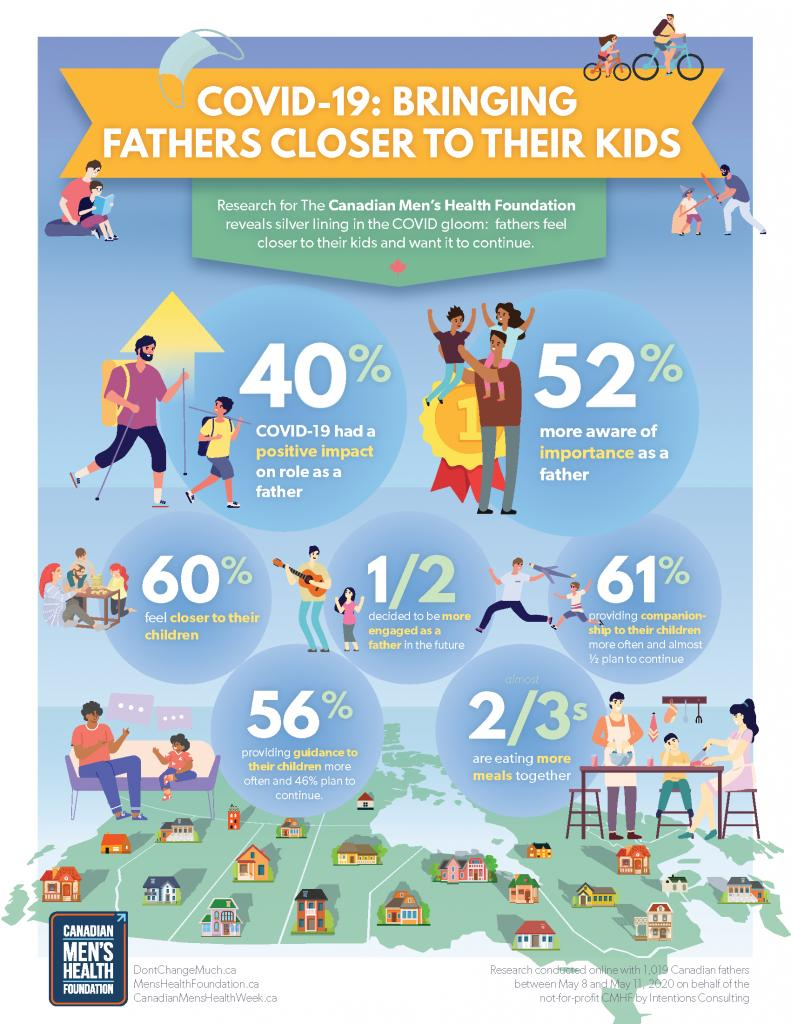Give some essential details in this illustration. According to a study conducted by the Canadian Mental Health Foundation, 60% of Canadian fathers reported feeling a stronger bond with their children during the COVID-19 pandemic. According to a study conducted by the Canadian Mental Health Foundation, a majority of Canadian fathers, 61%, provided companionship to their children more often during the COVID-19 period as compared to before the pandemic. According to the research conducted by CMHF, a significant portion of the Canadian men population has expressed a desire to be more engaged as a father in the future. According to the research conducted by the Canadian Mental Health Foundation, during the COVID-19 period, 56% of Canadian fathers were found to be providing guidance to their children more often, reflecting a positive change in parenting practices during the pandemic. According to the research conducted by CMHF, 52% of Canadian men are more aware of the importance of being a father. 